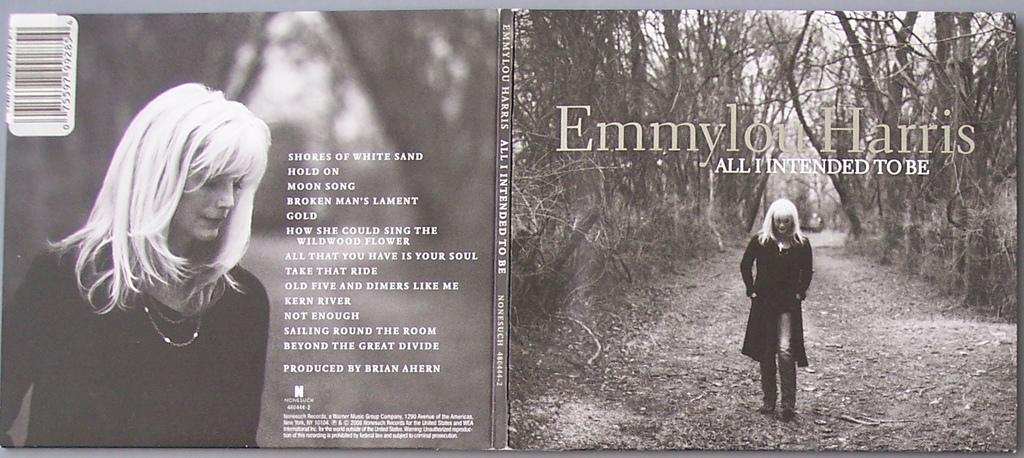What is the main object in the image? There is a magazine in the image. What can be found inside the magazine? There is an image of a woman in the magazine. What additional information is provided alongside the woman's image? There is information beside the woman's image. What is the name of the woman in the image? The woman's name is Emmylou Harris. How can the magazine be identified or scanned? There is a bar code on the top of the magazine. What type of development can be seen in the image? There is no development visible in the image; it features a magazine with an image of a woman and related information. Is there any dirt present in the image? There is no dirt present in the image; it is a magazine with an image of a woman and related information. 